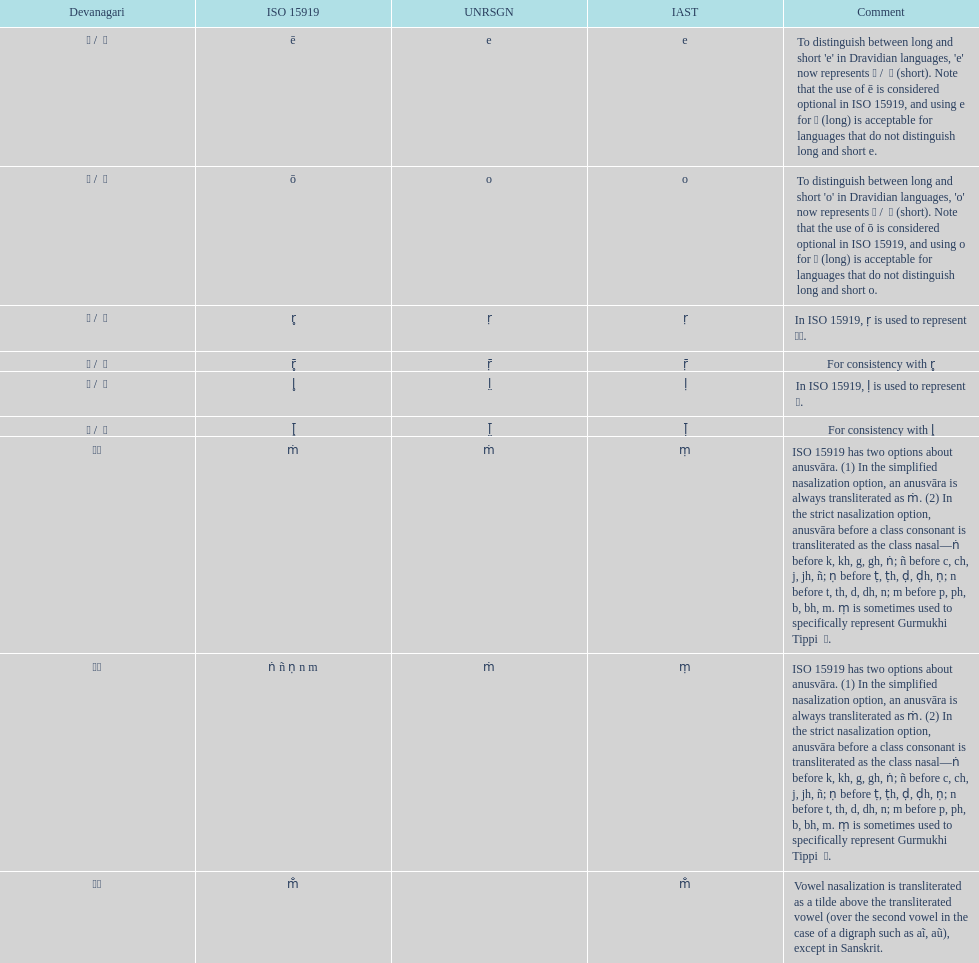Which devanagari transliteration is listed on the top of the table? ए / े. 